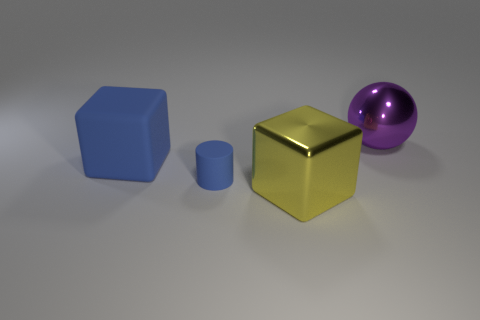What materials do these objects appear to be made of? The objects appear to be rendered with different types of materials. The large blue and small blue objects resemble a matte plastic finish, the gold object looks like a shiny metal, and the purple object has a glossy, reflective surface that might suggest a material like polished metal or glass. 